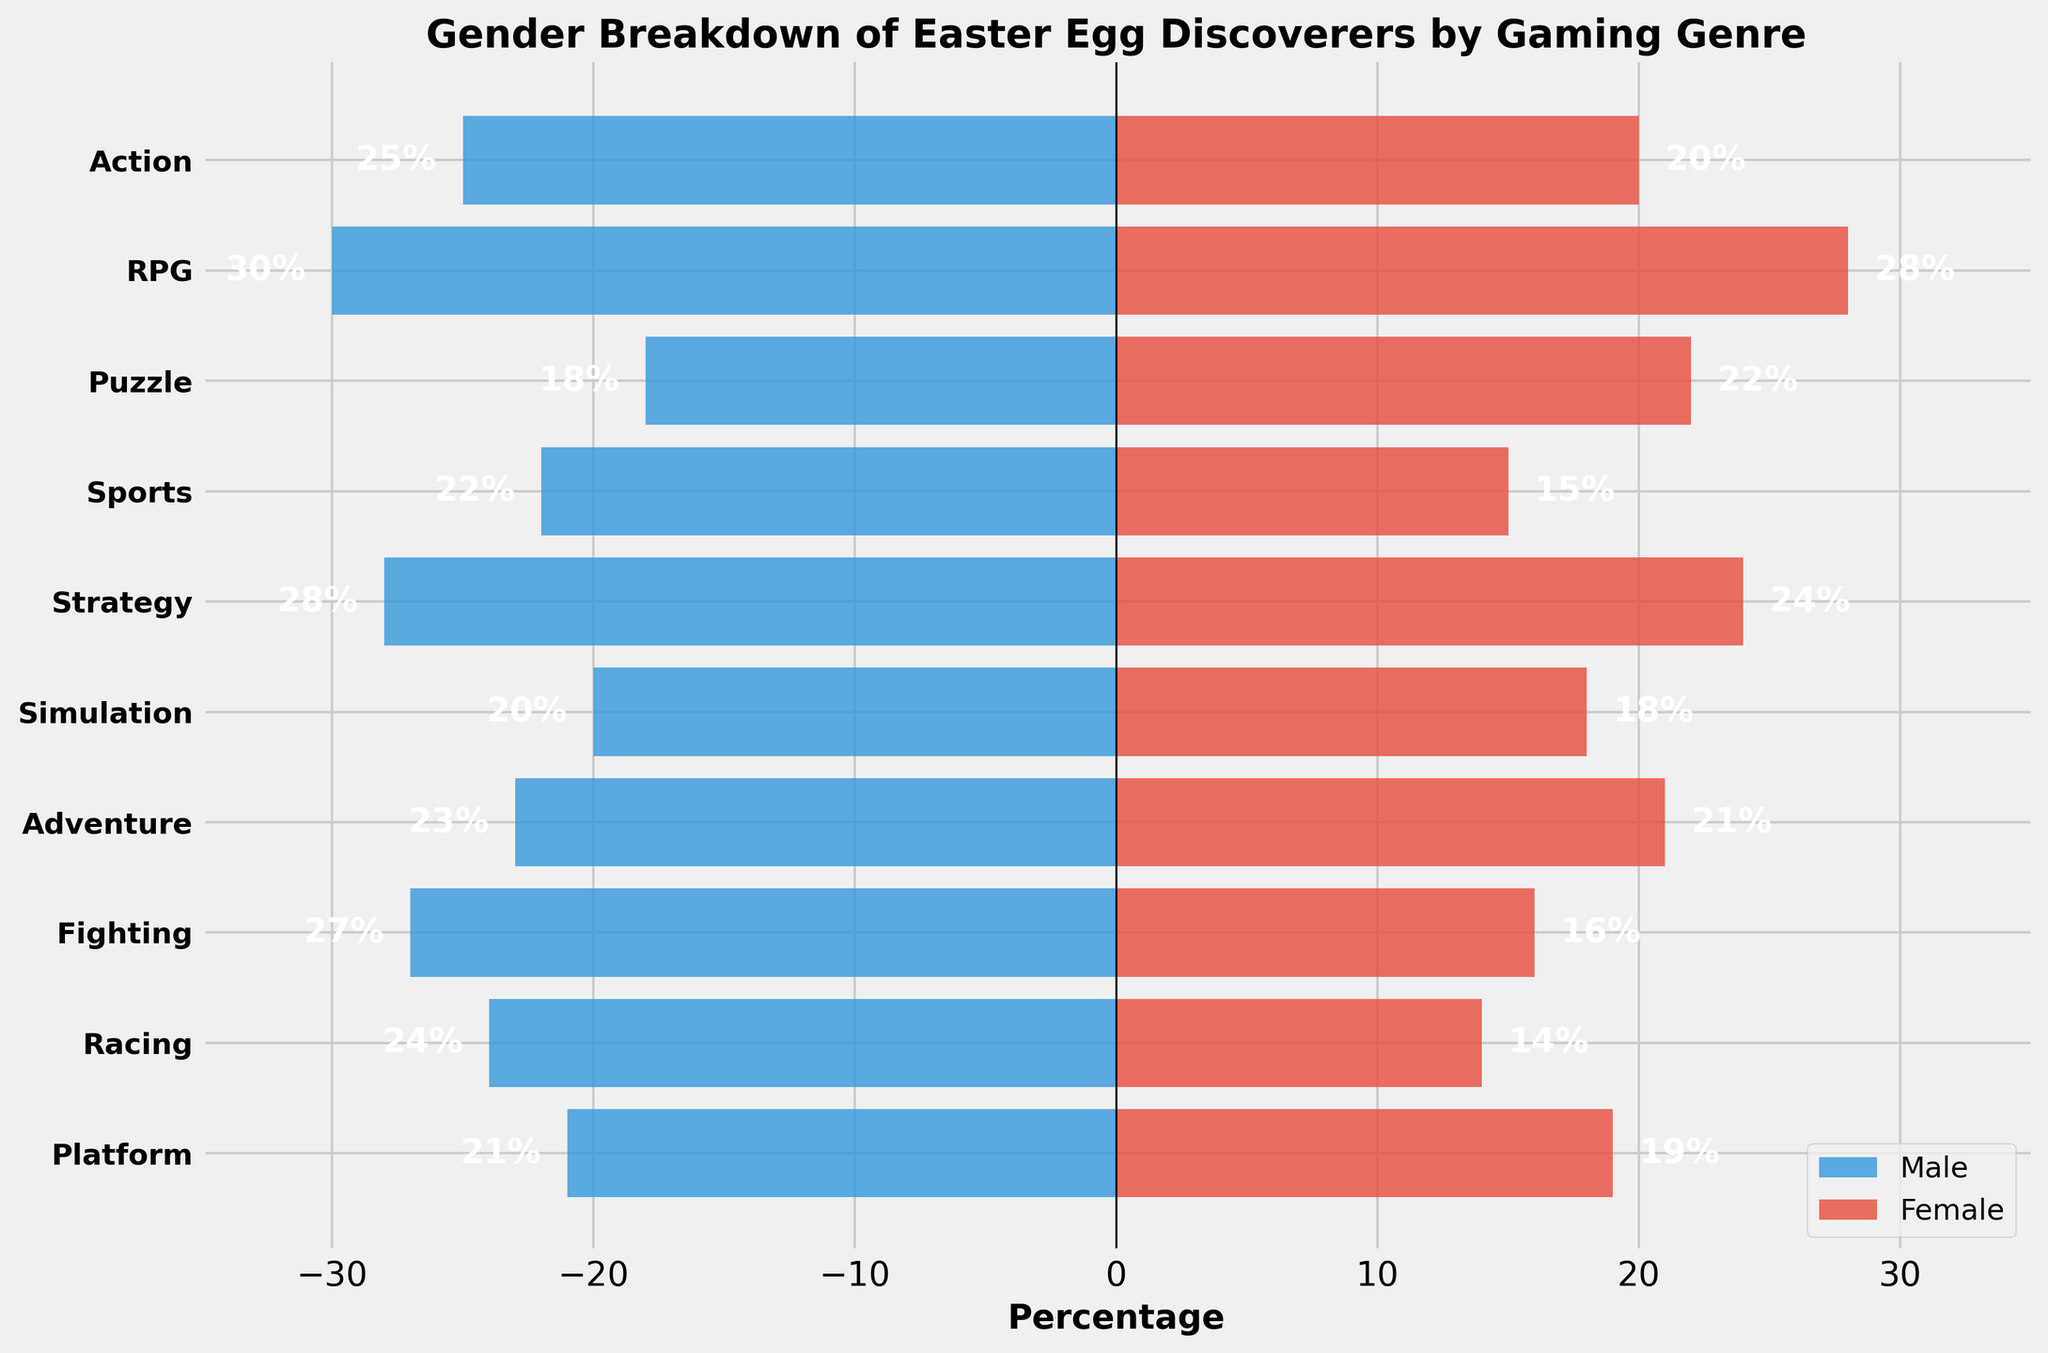what is the title of the plot? The title is usually found at the top of the plot. In this case, it reads "Gender Breakdown of Easter Egg Discoverers by Gaming Genre"
Answer: Gender Breakdown of Easter Egg Discoverers by Gaming Genre how many genres are analyzed in the figure? Count the number of different gaming genres listed on the y-axis. There are 10 unique genres.
Answer: 10 which genre has the highest percentage of female discoverers? The highest percentage of female discoverers is represented by the longest red bar on the right side. For RPG, the bar extends to 28%.
Answer: RPG what’s the difference in the percentage of male discoverers between Action and Puzzle genres? Look at the length of the blue bars for both Action and Puzzle genres and take the absolute value of their difference: abs(25 - 18)
Answer: 7 are there more female discoverers in Puzzle or Sports genres? Compare the lengths of the red bars for Puzzle (22%) and Sports (15%). Puzzle has the longer bar, indicating a higher percentage.
Answer: Puzzle what is the average percentage of female discoverers across all genres? Sum up the percentages of female discoverers across all genres and divide by the number of genres: (20+28+22+15+24+18+21+16+14+19)/10 = 197/10
Answer: 19.7% which genre has nearly equal male and female discoverers? Compare the lengths of blue and red bars for each genre. Simulation has male discoverers at 20% and female at 18%, which are close in numbers.
Answer: Simulation how do male discoverers in Racing compare with female discoverers in Adventure? Look at the lengths of the blue bar for Racing (24%) and the red bar for Adventure (21%). Racing has a higher percentage of male discoverers.
Answer: Racing has higher male discoverers which two genres have the closest total percentage of discoverers (male + female)? Add the percentages of male and female discoverers for each genre. Strategy (28+24=52) and Adventure (23+21=44) have the closest totals: 52 and 44 compared to other genres.
Answer: Strategy: 52 and Adventure: 44 which gender is dominant in the Simulation genre? Compare the lengths of the blue (male: 20%) and red bars (female: 18%) in Simulation. Males have a slightly higher percentage.
Answer: Males 